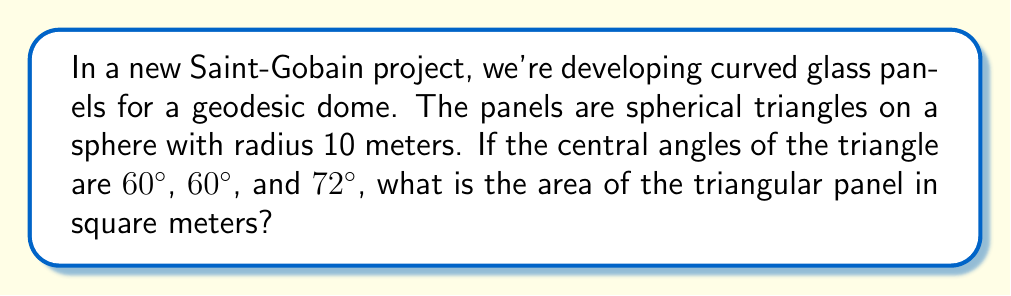Provide a solution to this math problem. Let's approach this step-by-step using spherical trigonometry:

1) The formula for the area $A$ of a spherical triangle on a sphere of radius $R$ is:

   $$A = R^2(A + B + C - \pi)$$

   where $A$, $B$, and $C$ are the angles of the spherical triangle in radians.

2) Convert the given angles from degrees to radians:
   
   60° = $\frac{\pi}{3}$ radians
   72° = $\frac{2\pi}{5}$ radians

3) Sum the angles:

   $$\frac{\pi}{3} + \frac{\pi}{3} + \frac{2\pi}{5} = \frac{10\pi}{15} + \frac{6\pi}{15} = \frac{16\pi}{15}$$

4) Subtract $\pi$:

   $$\frac{16\pi}{15} - \pi = \frac{16\pi}{15} - \frac{15\pi}{15} = \frac{\pi}{15}$$

5) Multiply by $R^2$ (remember, $R = 10$):

   $$A = 10^2 \cdot \frac{\pi}{15} = \frac{100\pi}{15} \approx 20.94$$

Thus, the area of the triangular panel is approximately 20.94 square meters.
Answer: $\frac{100\pi}{15}$ m² 